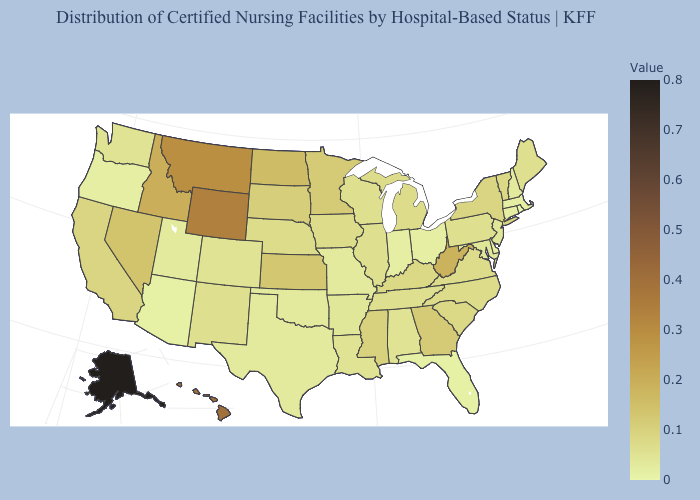Which states have the lowest value in the USA?
Short answer required. Rhode Island. Which states hav the highest value in the South?
Be succinct. West Virginia. Is the legend a continuous bar?
Concise answer only. Yes. Does Idaho have a higher value than Florida?
Answer briefly. Yes. Does New Hampshire have the lowest value in the Northeast?
Keep it brief. No. 